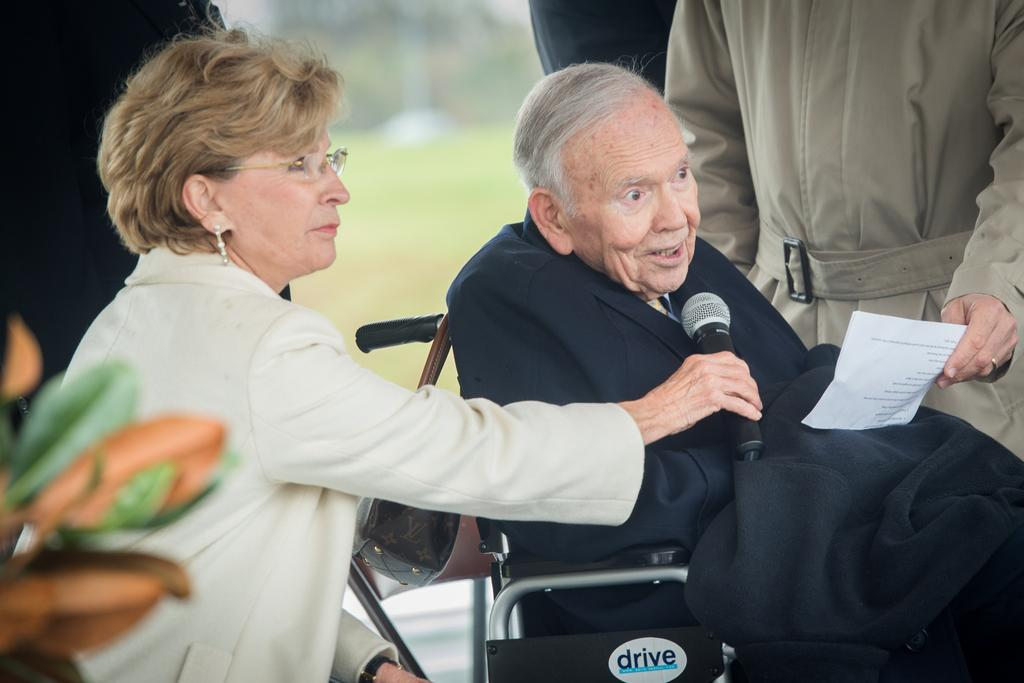What is the woman holding in the image? The woman is holding a microphone in the image. Where is the woman located in the image? The woman is on the left side of the image. What is the position of the person in the wheelchair in the image? The person in the wheelchair is on the right side of the image. What is the person holding a paper in the image doing? The person holding a paper in the image is likely reading or presenting the information on the paper. What type of story is being told by the pot in the image? There is no pot present in the image, so it is not possible to determine what type of story might be being told by the pot. 